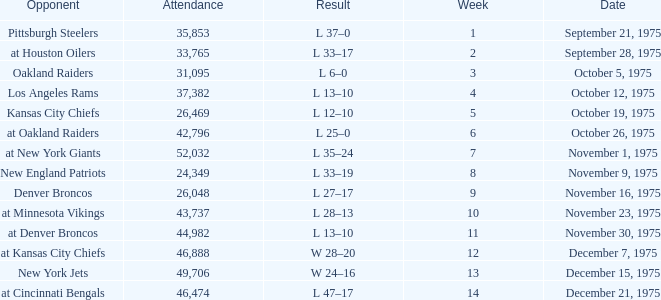What is the highest Week when the opponent was kansas city chiefs, with more than 26,469 in attendance? None. 